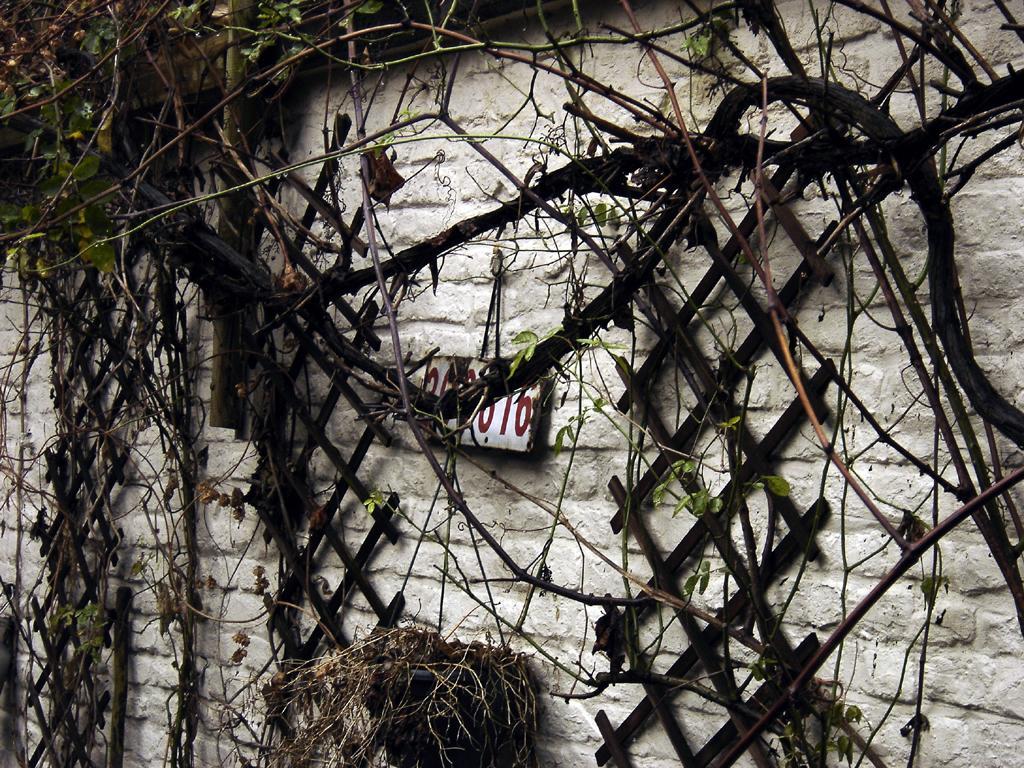Can you describe this image briefly? In this image there is a wall. There are wooden frames on the wall. In the center there is a board with numbers hanging on the wall. There are creepers and stems on the wall. 